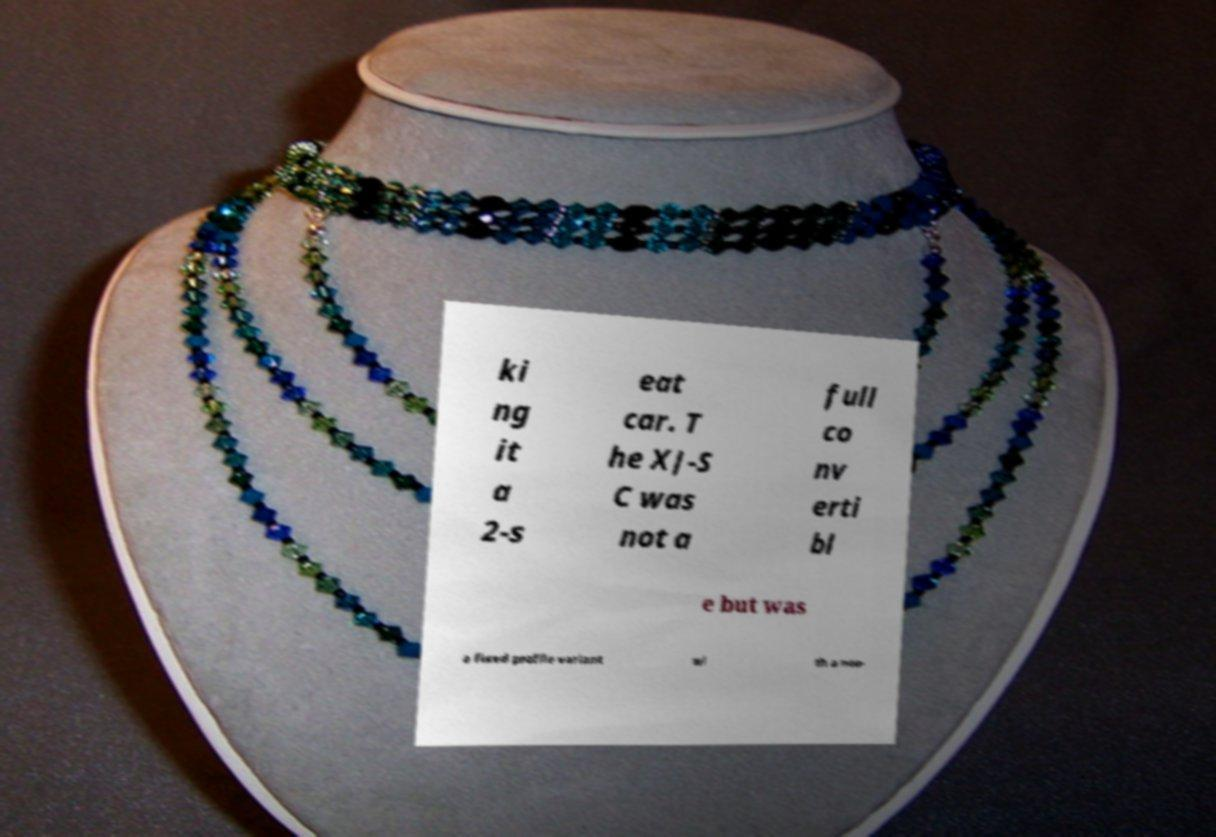Please read and relay the text visible in this image. What does it say? ki ng it a 2-s eat car. T he XJ-S C was not a full co nv erti bl e but was a fixed profile variant wi th a non- 